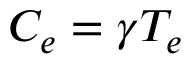<formula> <loc_0><loc_0><loc_500><loc_500>C _ { e } = \gamma T _ { e }</formula> 